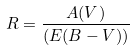<formula> <loc_0><loc_0><loc_500><loc_500>R = \frac { A ( V ) } { ( E ( B - V ) ) }</formula> 